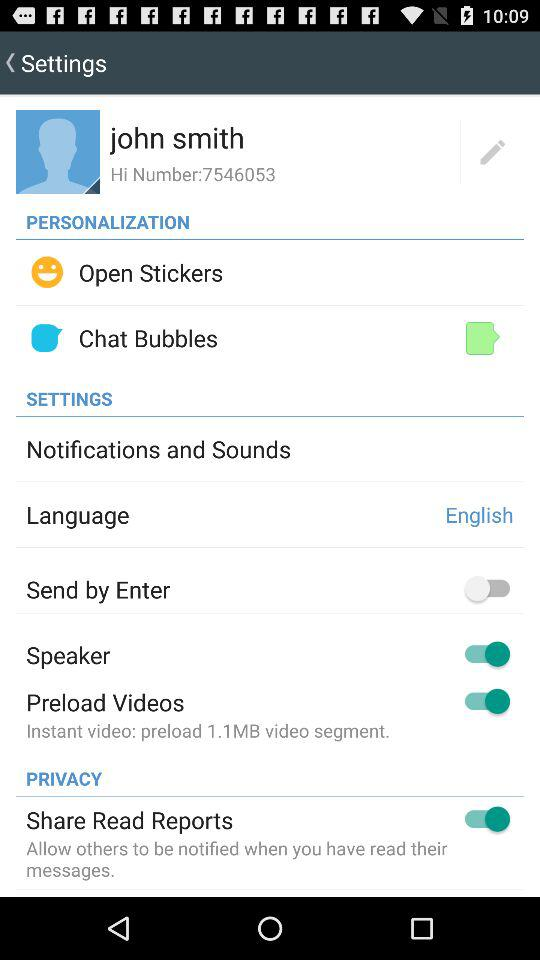Which settings is off? The setting is "Send by Enter". 